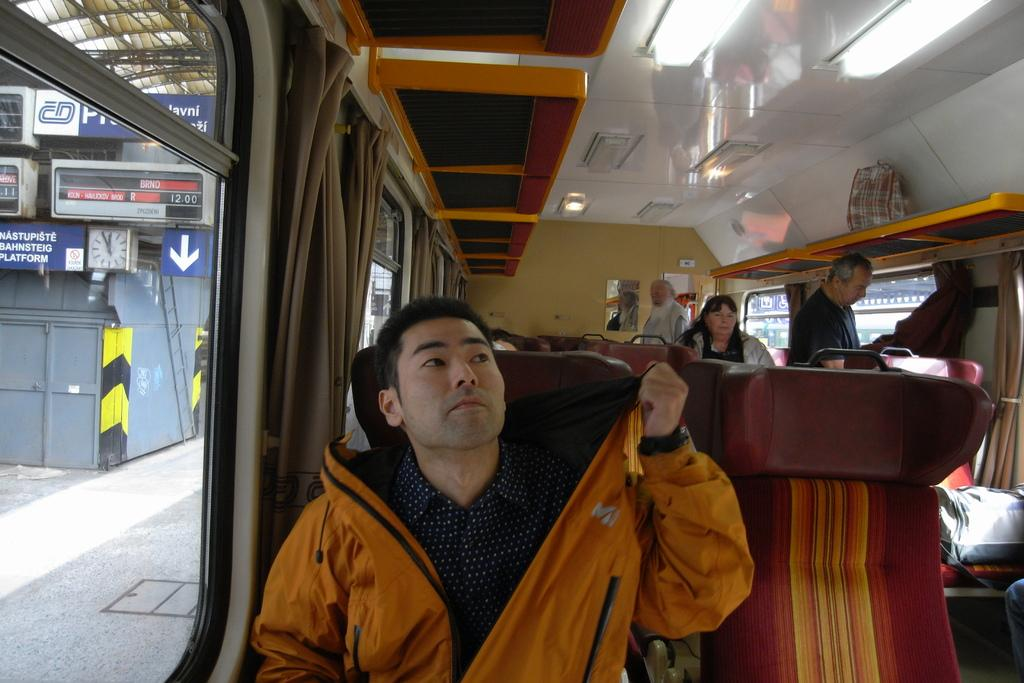What can be found inside the bus in the image? There are people in the bus. What type of window treatment is present in the bus? There are curtains in the bus. What is used for illumination in the bus? There are lights in the bus. What is visible on the left side of the image? There are hoardings and metal rods on the left side of the image. What type of thought is being expressed by the people in the bus? The image does not provide any information about the thoughts of the people in the bus, so it cannot be determined. --- Facts: 1. There is a person holding a book in the image. 2. The book has a blue cover. 3. The person is sitting on a chair. 4. There is a table in front of the person. 5. The table has a lamp on it. Absurd Topics: dance, ocean, parrot Conversation: What is the person in the image holding? The person in the image is holding a book. What color is the book's cover? The book has a blue cover. What is the person sitting on in the image? The person is sitting on a chair. What is present in front of the person? There is a table in front of the person. What is on the table? The table has a lamp on it. Reasoning: Let's think step by step in order to produce the conversation. We start by identifying the main subject in the image, which is the person holding a book. Then, we expand the conversation to include other details about the book, such as its color, and the person's seating arrangement. Finally, we describe the objects present on the table in front of the person, which is a lamp. Absurd Question/Answer: Can you see any parrots flying over the ocean in the image? There is no ocean or parrots present in the image; it features a person holding a book and sitting on a chair with a table and lamp nearby. 